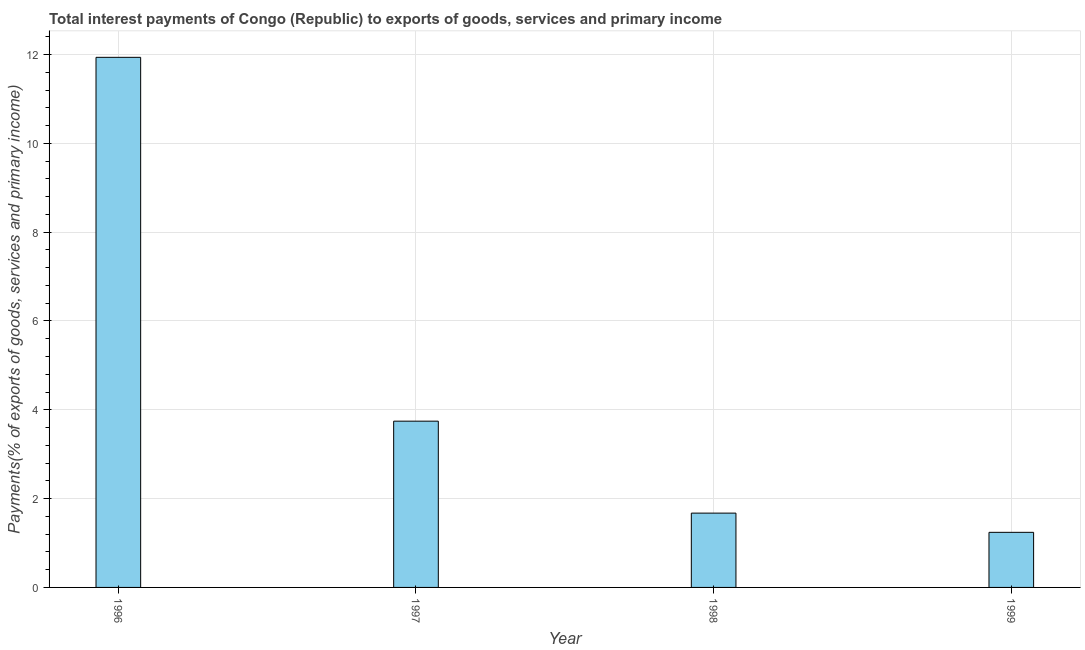Does the graph contain any zero values?
Provide a short and direct response. No. What is the title of the graph?
Ensure brevity in your answer.  Total interest payments of Congo (Republic) to exports of goods, services and primary income. What is the label or title of the X-axis?
Offer a terse response. Year. What is the label or title of the Y-axis?
Ensure brevity in your answer.  Payments(% of exports of goods, services and primary income). What is the total interest payments on external debt in 1996?
Keep it short and to the point. 11.94. Across all years, what is the maximum total interest payments on external debt?
Your response must be concise. 11.94. Across all years, what is the minimum total interest payments on external debt?
Provide a short and direct response. 1.24. In which year was the total interest payments on external debt maximum?
Provide a succinct answer. 1996. What is the sum of the total interest payments on external debt?
Provide a short and direct response. 18.6. What is the difference between the total interest payments on external debt in 1996 and 1999?
Make the answer very short. 10.7. What is the average total interest payments on external debt per year?
Your response must be concise. 4.65. What is the median total interest payments on external debt?
Your answer should be very brief. 2.71. In how many years, is the total interest payments on external debt greater than 10.4 %?
Make the answer very short. 1. What is the ratio of the total interest payments on external debt in 1998 to that in 1999?
Your response must be concise. 1.35. Is the total interest payments on external debt in 1998 less than that in 1999?
Your answer should be very brief. No. What is the difference between the highest and the second highest total interest payments on external debt?
Give a very brief answer. 8.19. What is the difference between the highest and the lowest total interest payments on external debt?
Give a very brief answer. 10.7. In how many years, is the total interest payments on external debt greater than the average total interest payments on external debt taken over all years?
Provide a short and direct response. 1. How many bars are there?
Keep it short and to the point. 4. How many years are there in the graph?
Your answer should be compact. 4. What is the difference between two consecutive major ticks on the Y-axis?
Offer a terse response. 2. What is the Payments(% of exports of goods, services and primary income) in 1996?
Your answer should be very brief. 11.94. What is the Payments(% of exports of goods, services and primary income) in 1997?
Offer a terse response. 3.74. What is the Payments(% of exports of goods, services and primary income) of 1998?
Give a very brief answer. 1.67. What is the Payments(% of exports of goods, services and primary income) of 1999?
Your response must be concise. 1.24. What is the difference between the Payments(% of exports of goods, services and primary income) in 1996 and 1997?
Offer a very short reply. 8.19. What is the difference between the Payments(% of exports of goods, services and primary income) in 1996 and 1998?
Offer a terse response. 10.26. What is the difference between the Payments(% of exports of goods, services and primary income) in 1996 and 1999?
Give a very brief answer. 10.7. What is the difference between the Payments(% of exports of goods, services and primary income) in 1997 and 1998?
Offer a very short reply. 2.07. What is the difference between the Payments(% of exports of goods, services and primary income) in 1997 and 1999?
Provide a succinct answer. 2.5. What is the difference between the Payments(% of exports of goods, services and primary income) in 1998 and 1999?
Your answer should be very brief. 0.43. What is the ratio of the Payments(% of exports of goods, services and primary income) in 1996 to that in 1997?
Offer a very short reply. 3.19. What is the ratio of the Payments(% of exports of goods, services and primary income) in 1996 to that in 1998?
Give a very brief answer. 7.13. What is the ratio of the Payments(% of exports of goods, services and primary income) in 1996 to that in 1999?
Ensure brevity in your answer.  9.62. What is the ratio of the Payments(% of exports of goods, services and primary income) in 1997 to that in 1998?
Your response must be concise. 2.24. What is the ratio of the Payments(% of exports of goods, services and primary income) in 1997 to that in 1999?
Your response must be concise. 3.02. What is the ratio of the Payments(% of exports of goods, services and primary income) in 1998 to that in 1999?
Give a very brief answer. 1.35. 